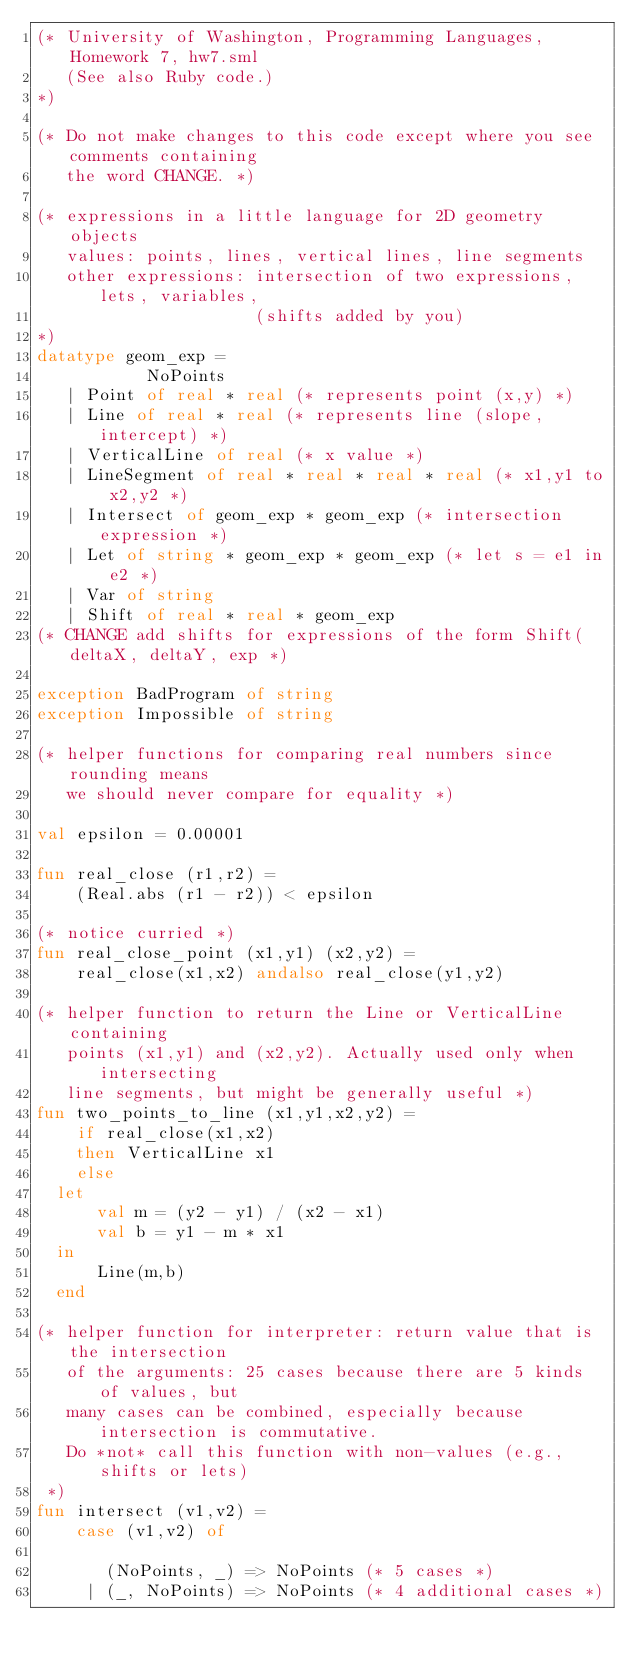Convert code to text. <code><loc_0><loc_0><loc_500><loc_500><_SML_>(* University of Washington, Programming Languages, Homework 7, hw7.sml 
   (See also Ruby code.)
*)

(* Do not make changes to this code except where you see comments containing
   the word CHANGE. *)

(* expressions in a little language for 2D geometry objects
   values: points, lines, vertical lines, line segments
   other expressions: intersection of two expressions, lets, variables, 
                      (shifts added by you)
*)
datatype geom_exp = 
           NoPoints
	 | Point of real * real (* represents point (x,y) *)
	 | Line of real * real (* represents line (slope, intercept) *)
	 | VerticalLine of real (* x value *)
	 | LineSegment of real * real * real * real (* x1,y1 to x2,y2 *)
	 | Intersect of geom_exp * geom_exp (* intersection expression *)
	 | Let of string * geom_exp * geom_exp (* let s = e1 in e2 *)
	 | Var of string
	 | Shift of real * real * geom_exp
(* CHANGE add shifts for expressions of the form Shift(deltaX, deltaY, exp *)

exception BadProgram of string
exception Impossible of string

(* helper functions for comparing real numbers since rounding means
   we should never compare for equality *)

val epsilon = 0.00001

fun real_close (r1,r2) = 
    (Real.abs (r1 - r2)) < epsilon

(* notice curried *)
fun real_close_point (x1,y1) (x2,y2) = 
    real_close(x1,x2) andalso real_close(y1,y2)

(* helper function to return the Line or VerticalLine containing 
   points (x1,y1) and (x2,y2). Actually used only when intersecting 
   line segments, but might be generally useful *)
fun two_points_to_line (x1,y1,x2,y2) = 
    if real_close(x1,x2)
    then VerticalLine x1
    else
	let 
	    val m = (y2 - y1) / (x2 - x1)
	    val b = y1 - m * x1
	in
	    Line(m,b)
	end

(* helper function for interpreter: return value that is the intersection
   of the arguments: 25 cases because there are 5 kinds of values, but
   many cases can be combined, especially because intersection is commutative.
   Do *not* call this function with non-values (e.g., shifts or lets)
 *)
fun intersect (v1,v2) =
    case (v1,v2) of
	
       (NoPoints, _) => NoPoints (* 5 cases *)
     | (_, NoPoints) => NoPoints (* 4 additional cases *)
</code> 